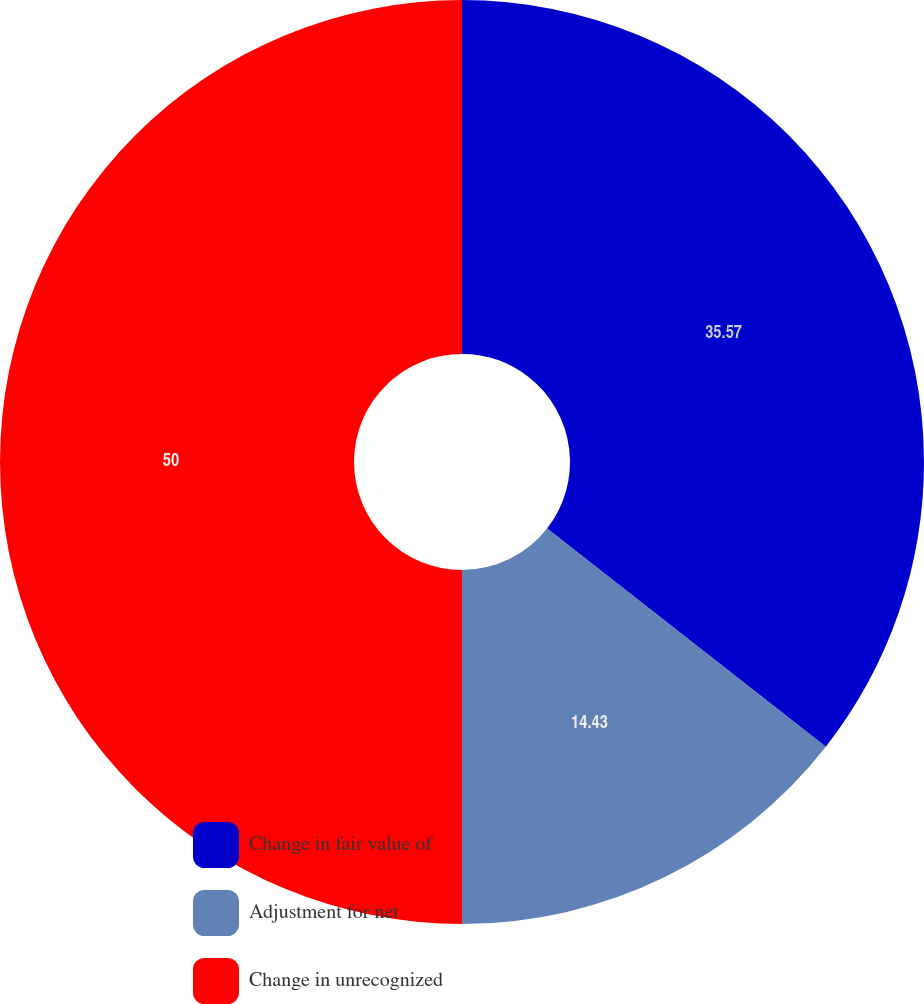Convert chart to OTSL. <chart><loc_0><loc_0><loc_500><loc_500><pie_chart><fcel>Change in fair value of<fcel>Adjustment for net<fcel>Change in unrecognized<nl><fcel>35.57%<fcel>14.43%<fcel>50.0%<nl></chart> 